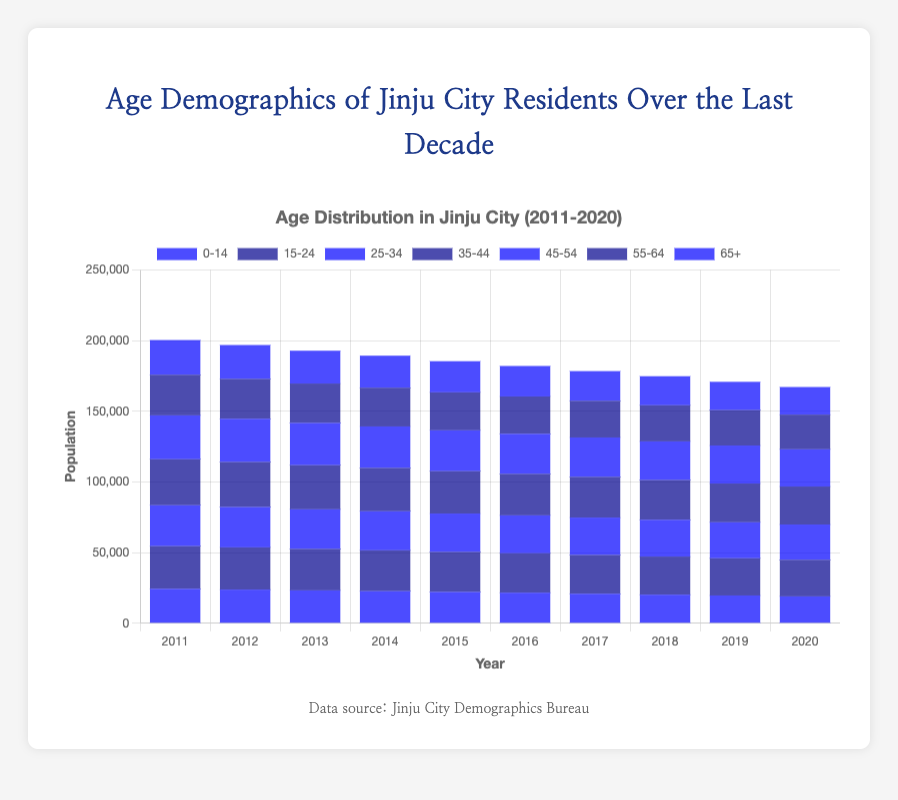What age group had the largest population in 2011? By looking at the height of the bars, we see that the "35-44" age group had the tallest bar for the year 2011, indicating the highest population count.
Answer: 35-44 Compare the population of the "65+" age group between 2011 and 2020. How did it change? The bar for the "65+" age group shows a population of 24567 in 2011 and 19545 in 2020. The change is 24567 - 19545 = 5022, indicating a decrease.
Answer: Decreased by 5022 Which age group showed the most significant decline over the last decade? By comparing the heights of the bars from 2011 to 2020 for each age group, the "0-14" age group had the most significant decline, from 24367 to 19045.
Answer: 0-14 How did the population of the "25-34" age group change from 2012 to 2016? The population of the "25-34" age group in 2012 was 28567, and in 2016 it was 26845. The change is 28567 - 26845 = 1722, indicating a decrease.
Answer: Decreased by 1722 Which two consecutive years had the most significant increase in the population for the "15-24" age group? Observing the bars for the "15-24" age group, the population decreased every year, so there was no increase during any two consecutive years.
Answer: No increase What was the total population of the "45-54" age group over the last decade? Adding the populations for the "45-54" age group from 2011 to 2020 gives: 31045 + 30567 + 29897 + 29345 + 28890 + 28356 + 27890 + 27345 + 26897 + 26345 = 286577.
Answer: 286577 Which year's data shows the highest total population across all age groups? By summing the heights of all the bars for each year, the highest total population is in 2011. Without summing, we can see 2011 has the highest stacked bar.
Answer: 2011 Compare the decline rate of the "0-14" and "65+" age groups from 2011 to 2020. Which group declined faster? Decline for "0-14": 24367 to 19045, which is 24367 - 19045 = 5322. Decline for "65+": 24567 to 19545, which is 24567 - 19545 = 5022. The "0-14" age group declined faster.
Answer: 0-14 Which age group displayed the most consistent population decline over the decade? The "15-24" age group shows a consistent year-on-year decline as each year's bar is slightly shorter than the previous year's bar.
Answer: 15-24 